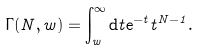Convert formula to latex. <formula><loc_0><loc_0><loc_500><loc_500>\Gamma ( N , w ) = \int _ { w } ^ { \infty } { \mathrm d } t { \mathrm e } ^ { - t } t ^ { N - 1 } .</formula> 